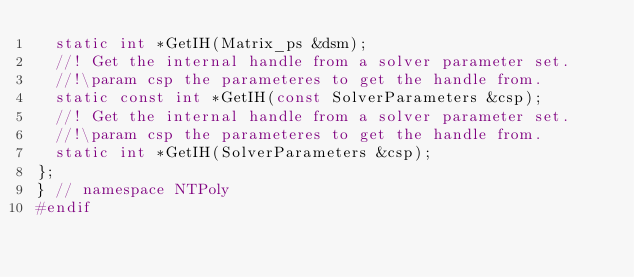<code> <loc_0><loc_0><loc_500><loc_500><_C_>  static int *GetIH(Matrix_ps &dsm);
  //! Get the internal handle from a solver parameter set.
  //!\param csp the parameteres to get the handle from.
  static const int *GetIH(const SolverParameters &csp);
  //! Get the internal handle from a solver parameter set.
  //!\param csp the parameteres to get the handle from.
  static int *GetIH(SolverParameters &csp);
};
} // namespace NTPoly
#endif
</code> 